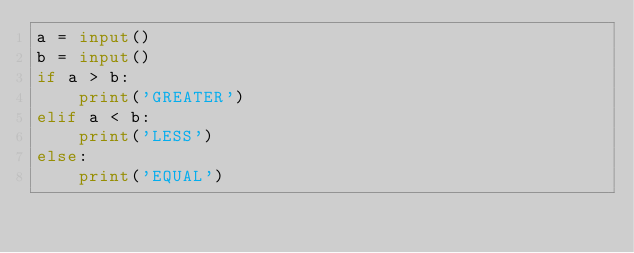<code> <loc_0><loc_0><loc_500><loc_500><_Python_>a = input()
b = input()
if a > b:
    print('GREATER')
elif a < b:
    print('LESS')
else:
    print('EQUAL')
</code> 